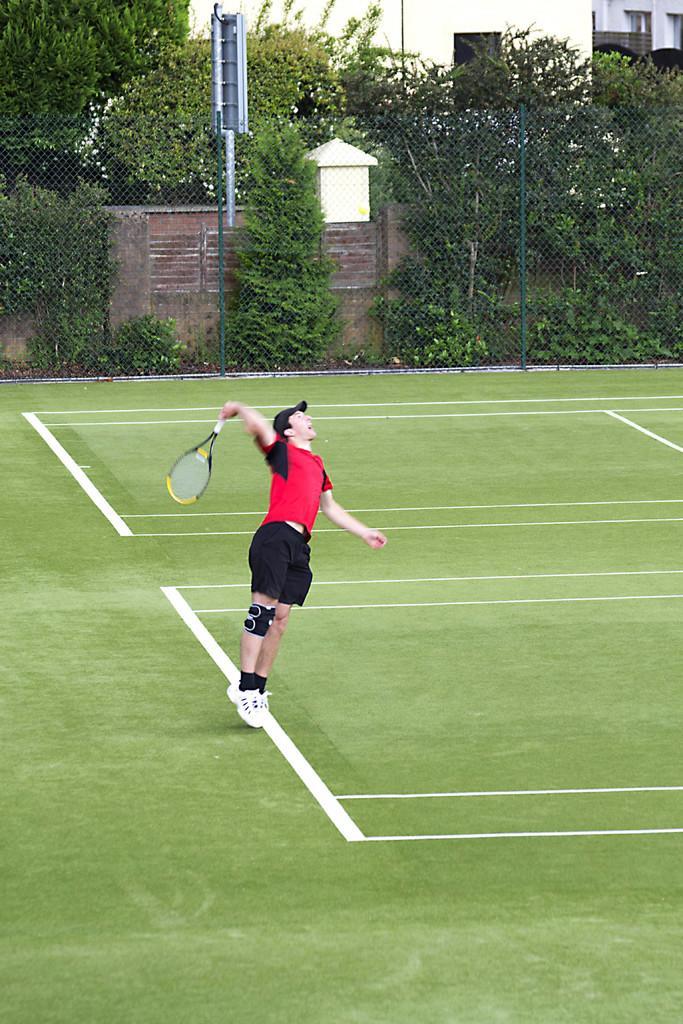Describe this image in one or two sentences. This is the man wearing red T-shirt,black short,cap and shoes. He is holding tennis racket. I think he is playing tennis. This looks like a tennis ground. These are the trees and small plants. This is a pole. I think this is a thin metal fencing sheet. This is the compound wall. I think these are the buildings. 